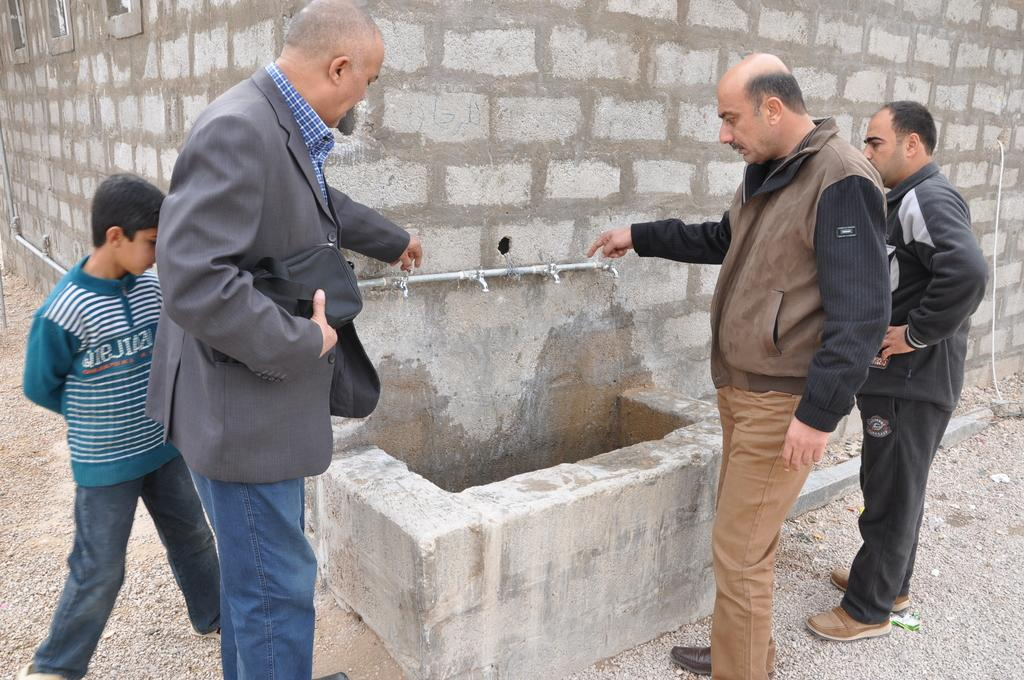How many people are in the image? There is a group of people in the image, but the exact number is not specified. What can be seen on the wall in front of the group of people? There are taps on the wall in front of the group of people. What type of fog can be seen surrounding the group of people in the image? There is no fog present in the image; it only shows a group of people and taps on the wall. 